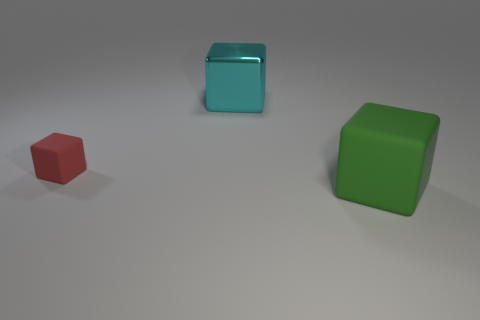Subtract all big blocks. How many blocks are left? 1 Add 1 small rubber cubes. How many objects exist? 4 Subtract all large matte cubes. Subtract all big cyan metallic objects. How many objects are left? 1 Add 3 small matte things. How many small matte things are left? 4 Add 3 red objects. How many red objects exist? 4 Subtract 0 blue cubes. How many objects are left? 3 